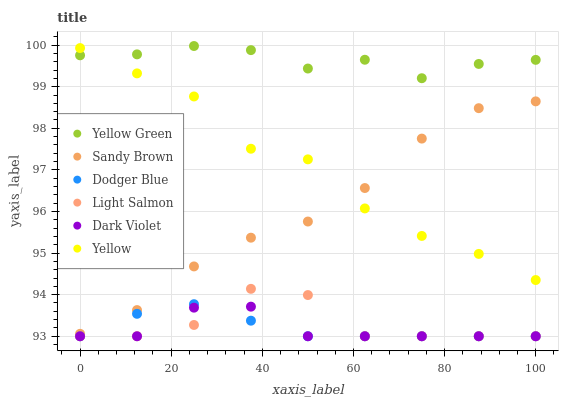Does Dark Violet have the minimum area under the curve?
Answer yes or no. Yes. Does Yellow Green have the maximum area under the curve?
Answer yes or no. Yes. Does Yellow have the minimum area under the curve?
Answer yes or no. No. Does Yellow have the maximum area under the curve?
Answer yes or no. No. Is Dodger Blue the smoothest?
Answer yes or no. Yes. Is Light Salmon the roughest?
Answer yes or no. Yes. Is Yellow Green the smoothest?
Answer yes or no. No. Is Yellow Green the roughest?
Answer yes or no. No. Does Light Salmon have the lowest value?
Answer yes or no. Yes. Does Yellow have the lowest value?
Answer yes or no. No. Does Yellow Green have the highest value?
Answer yes or no. Yes. Does Yellow have the highest value?
Answer yes or no. No. Is Dark Violet less than Yellow Green?
Answer yes or no. Yes. Is Sandy Brown greater than Dark Violet?
Answer yes or no. Yes. Does Dark Violet intersect Dodger Blue?
Answer yes or no. Yes. Is Dark Violet less than Dodger Blue?
Answer yes or no. No. Is Dark Violet greater than Dodger Blue?
Answer yes or no. No. Does Dark Violet intersect Yellow Green?
Answer yes or no. No. 